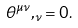<formula> <loc_0><loc_0><loc_500><loc_500>\theta ^ { \mu \nu } , _ { \nu } = 0 .</formula> 